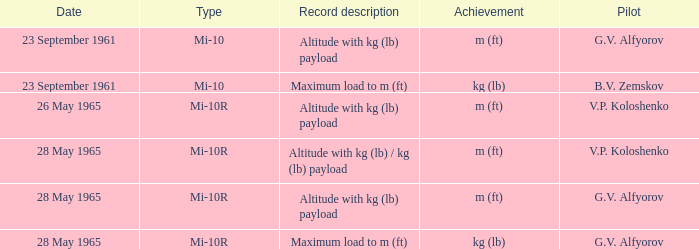Attainment of m (ft), and a category of mi-10r, and a pilot of v.p. koloshenko, and a date of 28 may 1965 had what record depiction? Altitude with kg (lb) / kg (lb) payload. 